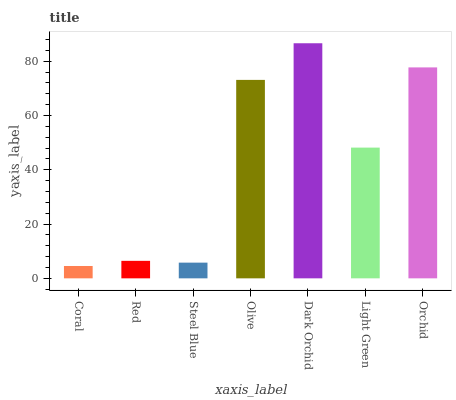Is Red the minimum?
Answer yes or no. No. Is Red the maximum?
Answer yes or no. No. Is Red greater than Coral?
Answer yes or no. Yes. Is Coral less than Red?
Answer yes or no. Yes. Is Coral greater than Red?
Answer yes or no. No. Is Red less than Coral?
Answer yes or no. No. Is Light Green the high median?
Answer yes or no. Yes. Is Light Green the low median?
Answer yes or no. Yes. Is Orchid the high median?
Answer yes or no. No. Is Steel Blue the low median?
Answer yes or no. No. 